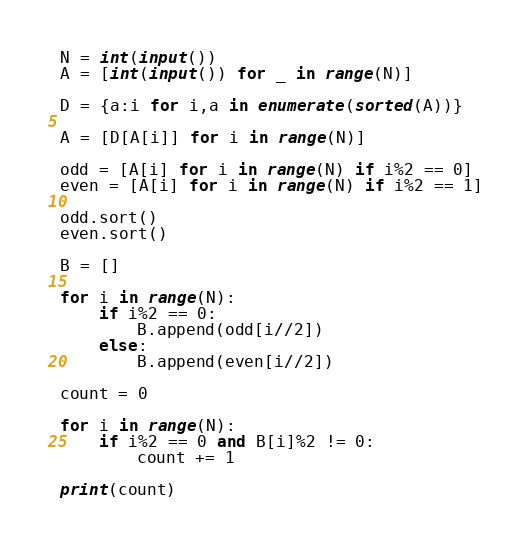<code> <loc_0><loc_0><loc_500><loc_500><_Python_>N = int(input())
A = [int(input()) for _ in range(N)]

D = {a:i for i,a in enumerate(sorted(A))}

A = [D[A[i]] for i in range(N)]

odd = [A[i] for i in range(N) if i%2 == 0]
even = [A[i] for i in range(N) if i%2 == 1]

odd.sort()
even.sort()

B = []

for i in range(N):
    if i%2 == 0:
        B.append(odd[i//2])
    else:
        B.append(even[i//2])

count = 0

for i in range(N):
    if i%2 == 0 and B[i]%2 != 0:
        count += 1

print(count)</code> 